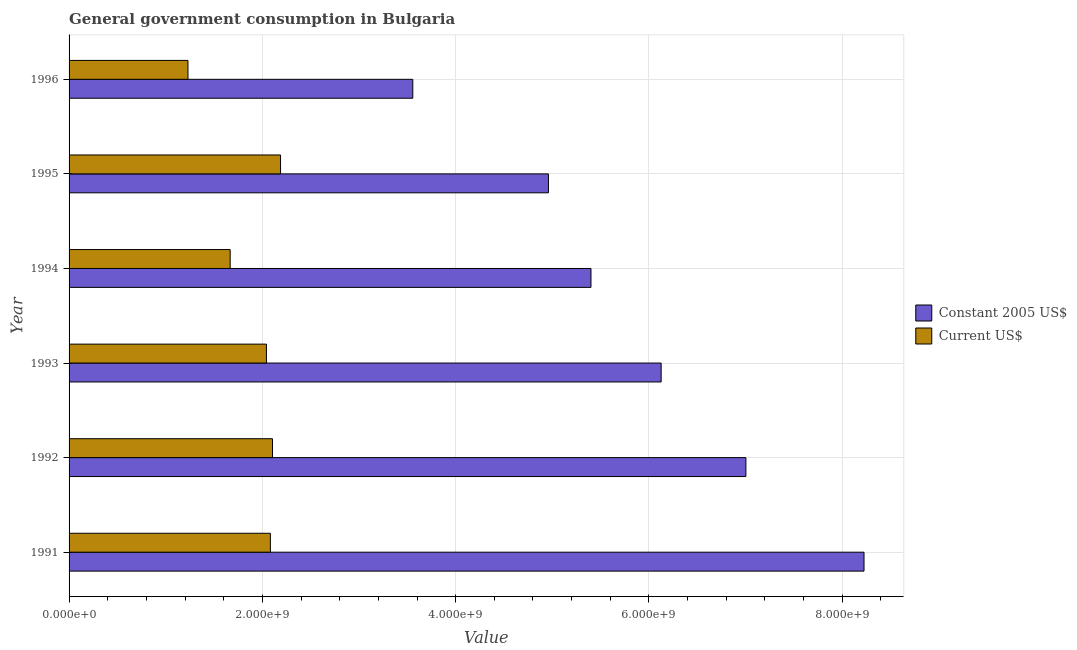How many different coloured bars are there?
Provide a succinct answer. 2. Are the number of bars on each tick of the Y-axis equal?
Provide a succinct answer. Yes. How many bars are there on the 5th tick from the bottom?
Provide a short and direct response. 2. What is the label of the 6th group of bars from the top?
Make the answer very short. 1991. In how many cases, is the number of bars for a given year not equal to the number of legend labels?
Provide a short and direct response. 0. What is the value consumed in current us$ in 1992?
Your answer should be very brief. 2.10e+09. Across all years, what is the maximum value consumed in current us$?
Provide a succinct answer. 2.19e+09. Across all years, what is the minimum value consumed in constant 2005 us$?
Give a very brief answer. 3.56e+09. In which year was the value consumed in constant 2005 us$ minimum?
Offer a terse response. 1996. What is the total value consumed in constant 2005 us$ in the graph?
Your response must be concise. 3.53e+1. What is the difference between the value consumed in constant 2005 us$ in 1993 and that in 1995?
Your answer should be compact. 1.17e+09. What is the difference between the value consumed in current us$ in 1993 and the value consumed in constant 2005 us$ in 1991?
Offer a very short reply. -6.18e+09. What is the average value consumed in constant 2005 us$ per year?
Ensure brevity in your answer.  5.88e+09. In the year 1994, what is the difference between the value consumed in constant 2005 us$ and value consumed in current us$?
Your answer should be compact. 3.73e+09. What is the ratio of the value consumed in constant 2005 us$ in 1991 to that in 1995?
Keep it short and to the point. 1.66. Is the value consumed in constant 2005 us$ in 1991 less than that in 1992?
Your answer should be very brief. No. What is the difference between the highest and the second highest value consumed in current us$?
Your response must be concise. 8.31e+07. What is the difference between the highest and the lowest value consumed in constant 2005 us$?
Make the answer very short. 4.67e+09. What does the 2nd bar from the top in 1991 represents?
Provide a succinct answer. Constant 2005 US$. What does the 1st bar from the bottom in 1994 represents?
Your response must be concise. Constant 2005 US$. How many years are there in the graph?
Provide a succinct answer. 6. Are the values on the major ticks of X-axis written in scientific E-notation?
Keep it short and to the point. Yes. Where does the legend appear in the graph?
Your response must be concise. Center right. How many legend labels are there?
Your answer should be compact. 2. How are the legend labels stacked?
Offer a terse response. Vertical. What is the title of the graph?
Offer a very short reply. General government consumption in Bulgaria. What is the label or title of the X-axis?
Offer a very short reply. Value. What is the label or title of the Y-axis?
Your answer should be compact. Year. What is the Value of Constant 2005 US$ in 1991?
Your answer should be very brief. 8.23e+09. What is the Value of Current US$ in 1991?
Provide a short and direct response. 2.08e+09. What is the Value in Constant 2005 US$ in 1992?
Ensure brevity in your answer.  7.00e+09. What is the Value in Current US$ in 1992?
Offer a terse response. 2.10e+09. What is the Value of Constant 2005 US$ in 1993?
Provide a short and direct response. 6.13e+09. What is the Value of Current US$ in 1993?
Ensure brevity in your answer.  2.04e+09. What is the Value of Constant 2005 US$ in 1994?
Make the answer very short. 5.40e+09. What is the Value of Current US$ in 1994?
Make the answer very short. 1.67e+09. What is the Value of Constant 2005 US$ in 1995?
Your response must be concise. 4.96e+09. What is the Value of Current US$ in 1995?
Make the answer very short. 2.19e+09. What is the Value of Constant 2005 US$ in 1996?
Keep it short and to the point. 3.56e+09. What is the Value in Current US$ in 1996?
Offer a terse response. 1.23e+09. Across all years, what is the maximum Value of Constant 2005 US$?
Your answer should be compact. 8.23e+09. Across all years, what is the maximum Value in Current US$?
Offer a terse response. 2.19e+09. Across all years, what is the minimum Value of Constant 2005 US$?
Your answer should be very brief. 3.56e+09. Across all years, what is the minimum Value of Current US$?
Offer a terse response. 1.23e+09. What is the total Value of Constant 2005 US$ in the graph?
Give a very brief answer. 3.53e+1. What is the total Value of Current US$ in the graph?
Provide a short and direct response. 1.13e+1. What is the difference between the Value in Constant 2005 US$ in 1991 and that in 1992?
Your answer should be compact. 1.22e+09. What is the difference between the Value of Current US$ in 1991 and that in 1992?
Provide a succinct answer. -2.20e+07. What is the difference between the Value of Constant 2005 US$ in 1991 and that in 1993?
Provide a succinct answer. 2.10e+09. What is the difference between the Value in Current US$ in 1991 and that in 1993?
Provide a succinct answer. 4.09e+07. What is the difference between the Value of Constant 2005 US$ in 1991 and that in 1994?
Your response must be concise. 2.83e+09. What is the difference between the Value of Current US$ in 1991 and that in 1994?
Your answer should be very brief. 4.16e+08. What is the difference between the Value of Constant 2005 US$ in 1991 and that in 1995?
Make the answer very short. 3.27e+09. What is the difference between the Value of Current US$ in 1991 and that in 1995?
Offer a terse response. -1.05e+08. What is the difference between the Value of Constant 2005 US$ in 1991 and that in 1996?
Make the answer very short. 4.67e+09. What is the difference between the Value of Current US$ in 1991 and that in 1996?
Your answer should be very brief. 8.53e+08. What is the difference between the Value in Constant 2005 US$ in 1992 and that in 1993?
Your answer should be compact. 8.77e+08. What is the difference between the Value in Current US$ in 1992 and that in 1993?
Provide a short and direct response. 6.29e+07. What is the difference between the Value of Constant 2005 US$ in 1992 and that in 1994?
Offer a very short reply. 1.60e+09. What is the difference between the Value of Current US$ in 1992 and that in 1994?
Keep it short and to the point. 4.38e+08. What is the difference between the Value in Constant 2005 US$ in 1992 and that in 1995?
Keep it short and to the point. 2.04e+09. What is the difference between the Value of Current US$ in 1992 and that in 1995?
Keep it short and to the point. -8.31e+07. What is the difference between the Value in Constant 2005 US$ in 1992 and that in 1996?
Provide a succinct answer. 3.45e+09. What is the difference between the Value of Current US$ in 1992 and that in 1996?
Your response must be concise. 8.75e+08. What is the difference between the Value of Constant 2005 US$ in 1993 and that in 1994?
Make the answer very short. 7.26e+08. What is the difference between the Value of Current US$ in 1993 and that in 1994?
Your answer should be very brief. 3.75e+08. What is the difference between the Value in Constant 2005 US$ in 1993 and that in 1995?
Offer a terse response. 1.17e+09. What is the difference between the Value in Current US$ in 1993 and that in 1995?
Your answer should be compact. -1.46e+08. What is the difference between the Value in Constant 2005 US$ in 1993 and that in 1996?
Keep it short and to the point. 2.57e+09. What is the difference between the Value in Current US$ in 1993 and that in 1996?
Offer a very short reply. 8.12e+08. What is the difference between the Value of Constant 2005 US$ in 1994 and that in 1995?
Your answer should be compact. 4.40e+08. What is the difference between the Value in Current US$ in 1994 and that in 1995?
Offer a terse response. -5.21e+08. What is the difference between the Value of Constant 2005 US$ in 1994 and that in 1996?
Offer a very short reply. 1.84e+09. What is the difference between the Value of Current US$ in 1994 and that in 1996?
Provide a short and direct response. 4.37e+08. What is the difference between the Value of Constant 2005 US$ in 1995 and that in 1996?
Your answer should be compact. 1.40e+09. What is the difference between the Value in Current US$ in 1995 and that in 1996?
Keep it short and to the point. 9.58e+08. What is the difference between the Value of Constant 2005 US$ in 1991 and the Value of Current US$ in 1992?
Keep it short and to the point. 6.12e+09. What is the difference between the Value in Constant 2005 US$ in 1991 and the Value in Current US$ in 1993?
Your answer should be very brief. 6.18e+09. What is the difference between the Value of Constant 2005 US$ in 1991 and the Value of Current US$ in 1994?
Your response must be concise. 6.56e+09. What is the difference between the Value of Constant 2005 US$ in 1991 and the Value of Current US$ in 1995?
Offer a terse response. 6.04e+09. What is the difference between the Value of Constant 2005 US$ in 1991 and the Value of Current US$ in 1996?
Offer a terse response. 6.99e+09. What is the difference between the Value of Constant 2005 US$ in 1992 and the Value of Current US$ in 1993?
Make the answer very short. 4.96e+09. What is the difference between the Value in Constant 2005 US$ in 1992 and the Value in Current US$ in 1994?
Your answer should be compact. 5.34e+09. What is the difference between the Value of Constant 2005 US$ in 1992 and the Value of Current US$ in 1995?
Offer a terse response. 4.81e+09. What is the difference between the Value of Constant 2005 US$ in 1992 and the Value of Current US$ in 1996?
Offer a very short reply. 5.77e+09. What is the difference between the Value of Constant 2005 US$ in 1993 and the Value of Current US$ in 1994?
Provide a succinct answer. 4.46e+09. What is the difference between the Value in Constant 2005 US$ in 1993 and the Value in Current US$ in 1995?
Give a very brief answer. 3.94e+09. What is the difference between the Value in Constant 2005 US$ in 1993 and the Value in Current US$ in 1996?
Make the answer very short. 4.90e+09. What is the difference between the Value in Constant 2005 US$ in 1994 and the Value in Current US$ in 1995?
Offer a very short reply. 3.21e+09. What is the difference between the Value of Constant 2005 US$ in 1994 and the Value of Current US$ in 1996?
Make the answer very short. 4.17e+09. What is the difference between the Value in Constant 2005 US$ in 1995 and the Value in Current US$ in 1996?
Your answer should be very brief. 3.73e+09. What is the average Value of Constant 2005 US$ per year?
Provide a succinct answer. 5.88e+09. What is the average Value of Current US$ per year?
Provide a short and direct response. 1.89e+09. In the year 1991, what is the difference between the Value in Constant 2005 US$ and Value in Current US$?
Your answer should be very brief. 6.14e+09. In the year 1992, what is the difference between the Value in Constant 2005 US$ and Value in Current US$?
Keep it short and to the point. 4.90e+09. In the year 1993, what is the difference between the Value in Constant 2005 US$ and Value in Current US$?
Make the answer very short. 4.08e+09. In the year 1994, what is the difference between the Value of Constant 2005 US$ and Value of Current US$?
Provide a succinct answer. 3.73e+09. In the year 1995, what is the difference between the Value of Constant 2005 US$ and Value of Current US$?
Make the answer very short. 2.77e+09. In the year 1996, what is the difference between the Value of Constant 2005 US$ and Value of Current US$?
Offer a very short reply. 2.33e+09. What is the ratio of the Value of Constant 2005 US$ in 1991 to that in 1992?
Provide a succinct answer. 1.17. What is the ratio of the Value in Constant 2005 US$ in 1991 to that in 1993?
Your answer should be very brief. 1.34. What is the ratio of the Value in Current US$ in 1991 to that in 1993?
Your response must be concise. 1.02. What is the ratio of the Value of Constant 2005 US$ in 1991 to that in 1994?
Your response must be concise. 1.52. What is the ratio of the Value in Current US$ in 1991 to that in 1994?
Your answer should be compact. 1.25. What is the ratio of the Value of Constant 2005 US$ in 1991 to that in 1995?
Ensure brevity in your answer.  1.66. What is the ratio of the Value in Constant 2005 US$ in 1991 to that in 1996?
Offer a terse response. 2.31. What is the ratio of the Value in Current US$ in 1991 to that in 1996?
Ensure brevity in your answer.  1.69. What is the ratio of the Value of Constant 2005 US$ in 1992 to that in 1993?
Your answer should be very brief. 1.14. What is the ratio of the Value in Current US$ in 1992 to that in 1993?
Offer a terse response. 1.03. What is the ratio of the Value of Constant 2005 US$ in 1992 to that in 1994?
Offer a terse response. 1.3. What is the ratio of the Value of Current US$ in 1992 to that in 1994?
Give a very brief answer. 1.26. What is the ratio of the Value of Constant 2005 US$ in 1992 to that in 1995?
Your answer should be compact. 1.41. What is the ratio of the Value in Constant 2005 US$ in 1992 to that in 1996?
Your answer should be compact. 1.97. What is the ratio of the Value of Current US$ in 1992 to that in 1996?
Your answer should be very brief. 1.71. What is the ratio of the Value of Constant 2005 US$ in 1993 to that in 1994?
Make the answer very short. 1.13. What is the ratio of the Value of Current US$ in 1993 to that in 1994?
Ensure brevity in your answer.  1.23. What is the ratio of the Value in Constant 2005 US$ in 1993 to that in 1995?
Offer a terse response. 1.24. What is the ratio of the Value in Current US$ in 1993 to that in 1995?
Offer a terse response. 0.93. What is the ratio of the Value in Constant 2005 US$ in 1993 to that in 1996?
Your answer should be very brief. 1.72. What is the ratio of the Value in Current US$ in 1993 to that in 1996?
Keep it short and to the point. 1.66. What is the ratio of the Value of Constant 2005 US$ in 1994 to that in 1995?
Offer a very short reply. 1.09. What is the ratio of the Value in Current US$ in 1994 to that in 1995?
Your answer should be very brief. 0.76. What is the ratio of the Value in Constant 2005 US$ in 1994 to that in 1996?
Make the answer very short. 1.52. What is the ratio of the Value of Current US$ in 1994 to that in 1996?
Offer a very short reply. 1.35. What is the ratio of the Value of Constant 2005 US$ in 1995 to that in 1996?
Provide a succinct answer. 1.39. What is the ratio of the Value in Current US$ in 1995 to that in 1996?
Provide a succinct answer. 1.78. What is the difference between the highest and the second highest Value of Constant 2005 US$?
Offer a very short reply. 1.22e+09. What is the difference between the highest and the second highest Value in Current US$?
Your answer should be very brief. 8.31e+07. What is the difference between the highest and the lowest Value in Constant 2005 US$?
Your answer should be compact. 4.67e+09. What is the difference between the highest and the lowest Value in Current US$?
Make the answer very short. 9.58e+08. 